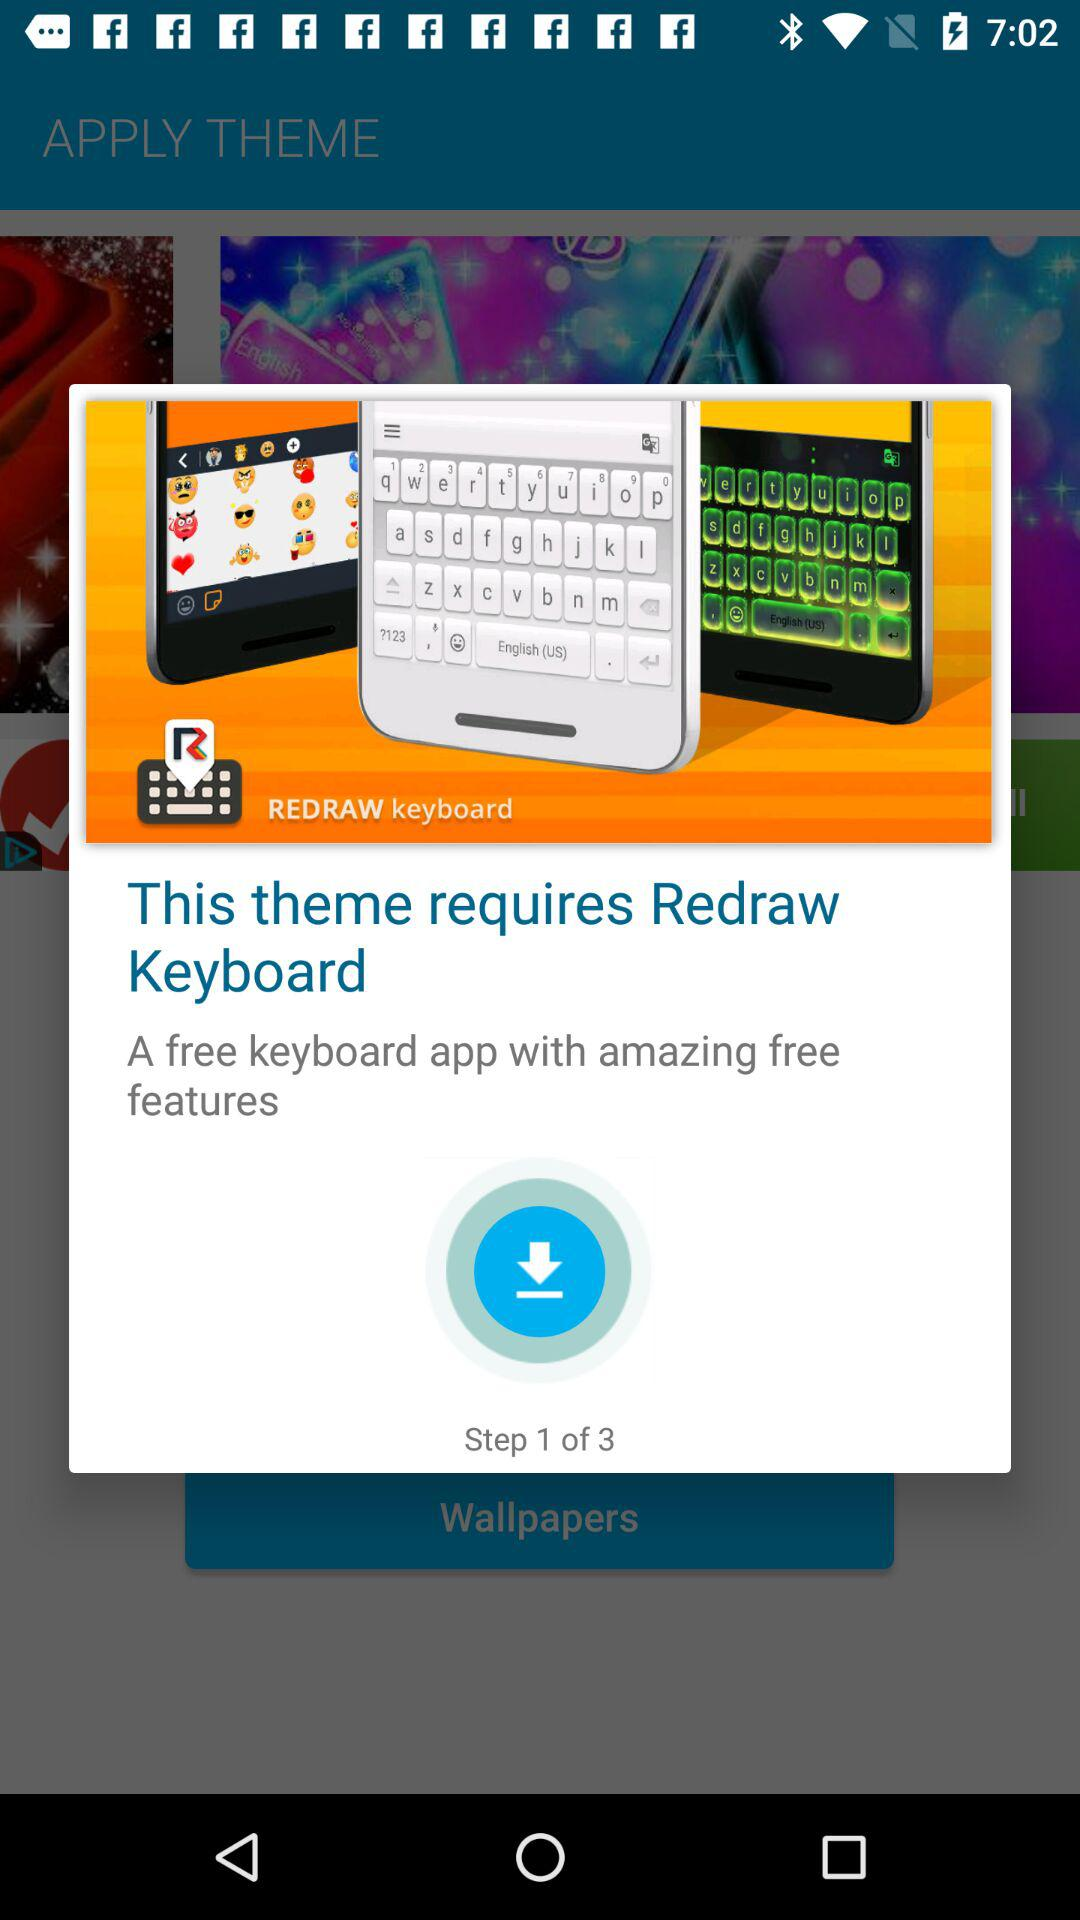How many steps are there in the process?
Answer the question using a single word or phrase. 3 